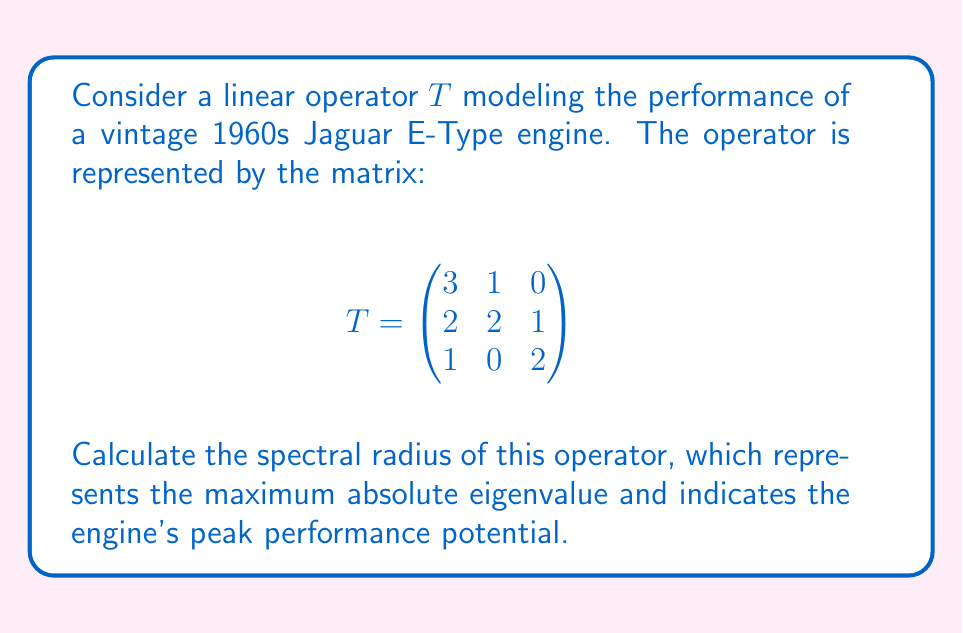Can you solve this math problem? To find the spectral radius, we need to:

1. Calculate the characteristic polynomial of $T$:
   $det(T - \lambda I) = \begin{vmatrix}
   3-\lambda & 1 & 0 \\
   2 & 2-\lambda & 1 \\
   1 & 0 & 2-\lambda
   \end{vmatrix}$

2. Expand the determinant:
   $(3-\lambda)[(2-\lambda)(2-\lambda)-0] - 1[2(2-\lambda)-1] + 0$
   $= (3-\lambda)[(4-4\lambda+\lambda^2)] - [4-2\lambda-1]$
   $= 12-12\lambda+3\lambda^2-4\lambda+4\lambda^2-\lambda^3 - 3 + 2\lambda$
   $= -\lambda^3 + 7\lambda^2 - 14\lambda + 9$

3. Find the roots of the characteristic polynomial:
   The roots are the eigenvalues. Using the cubic formula or numerical methods, we get:
   $\lambda_1 \approx 4.2915$
   $\lambda_2 \approx 1.5236$
   $\lambda_3 \approx 1.1849$

4. The spectral radius is the maximum absolute value of the eigenvalues:
   $\rho(T) = \max\{|\lambda_1|, |\lambda_2|, |\lambda_3|\} = |\lambda_1| \approx 4.2915$

This value represents the peak performance potential of the vintage Jaguar E-Type engine in our model.
Answer: $4.2915$ 